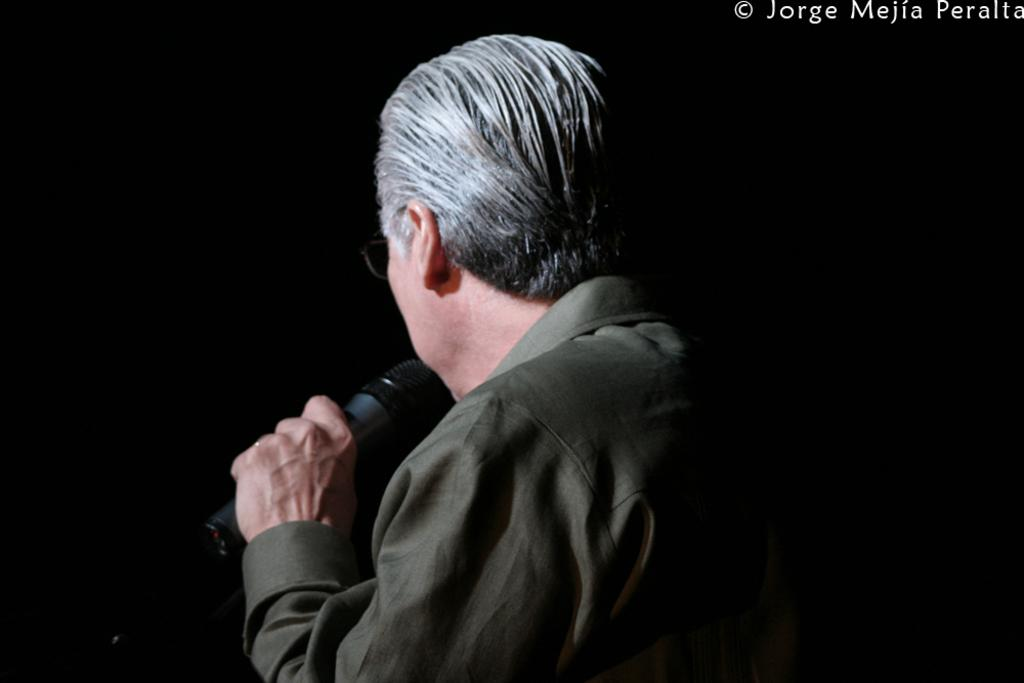What is the man in the image holding in his hand? The man is holding a mic in his hand. What color is the shirt the man is wearing? The man is wearing a gray color shirt. What can be observed about the man's hair? The man's hair is white in color. What accessory is the man wearing on his face? The man is wearing spectacles. What type of jam is the man spreading on the fish in the image? There is no jam or fish present in the image; the man is holding a mic and wearing a gray shirt, white hair, and spectacles. 